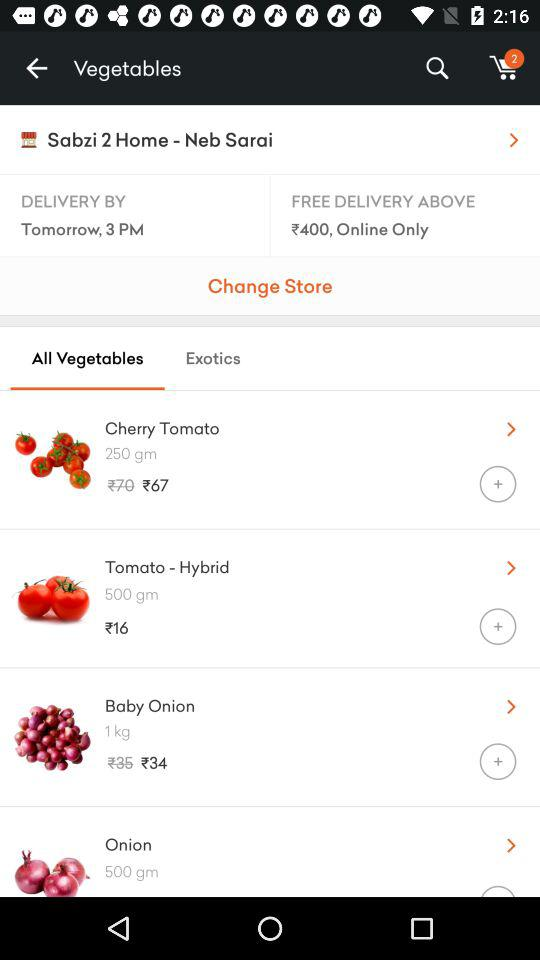What is the quantity of "Onion"? The quantity of "Onion" is 500 grams. 